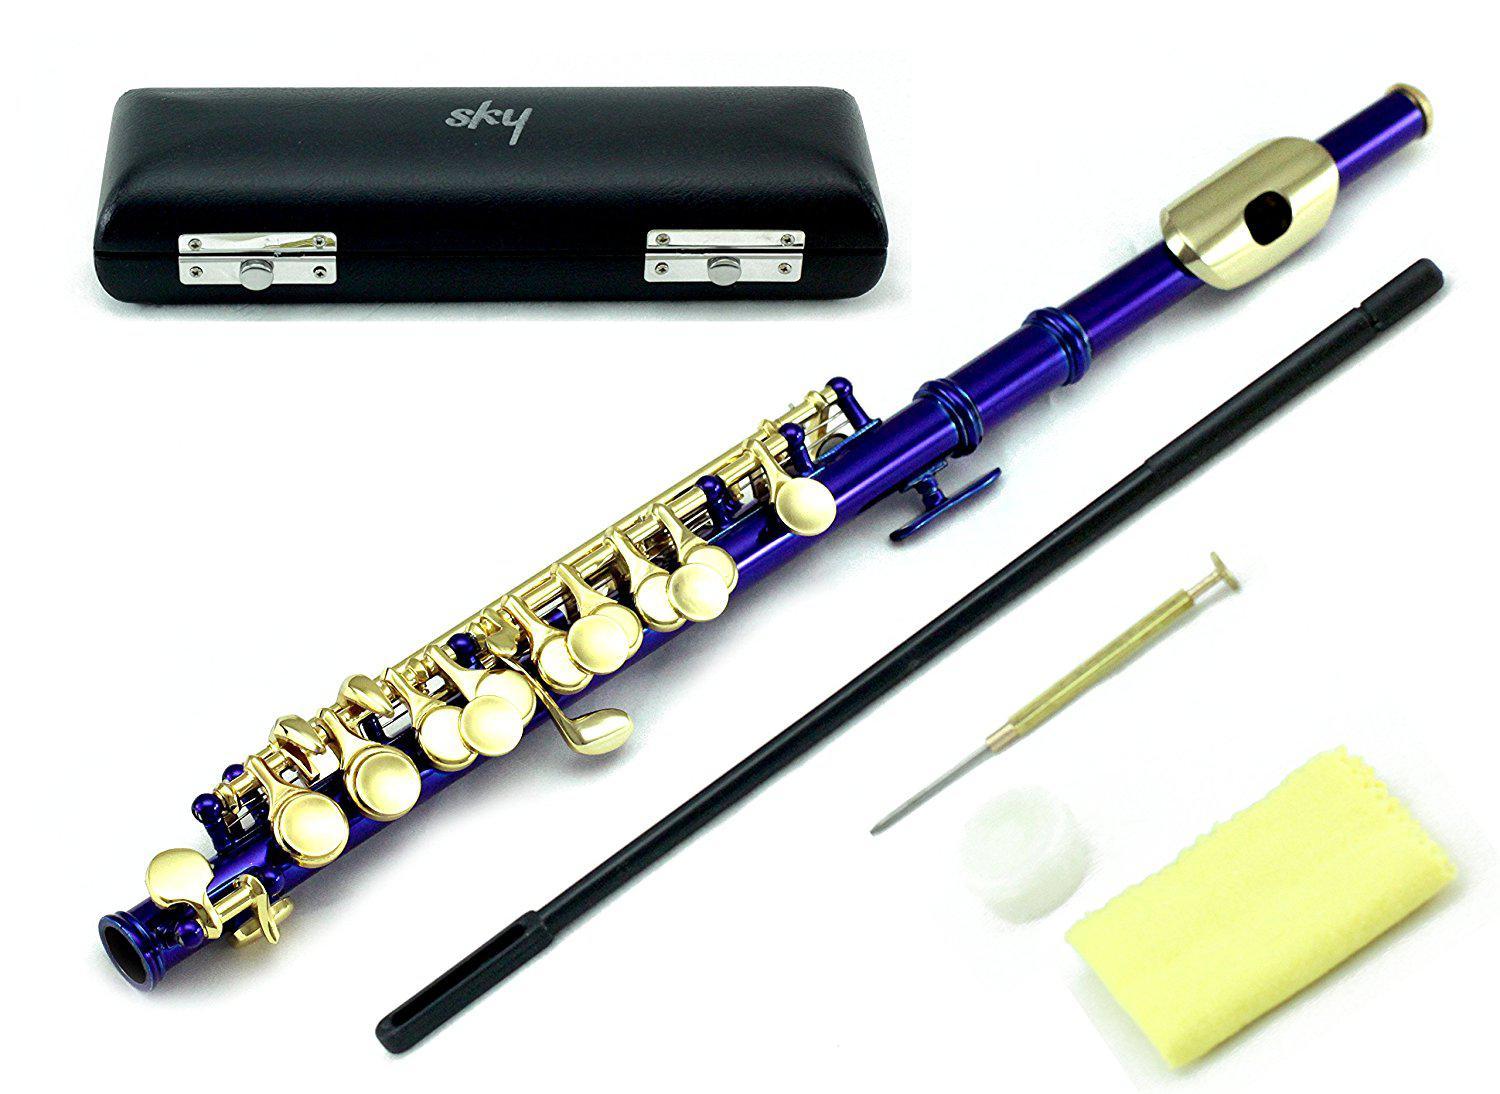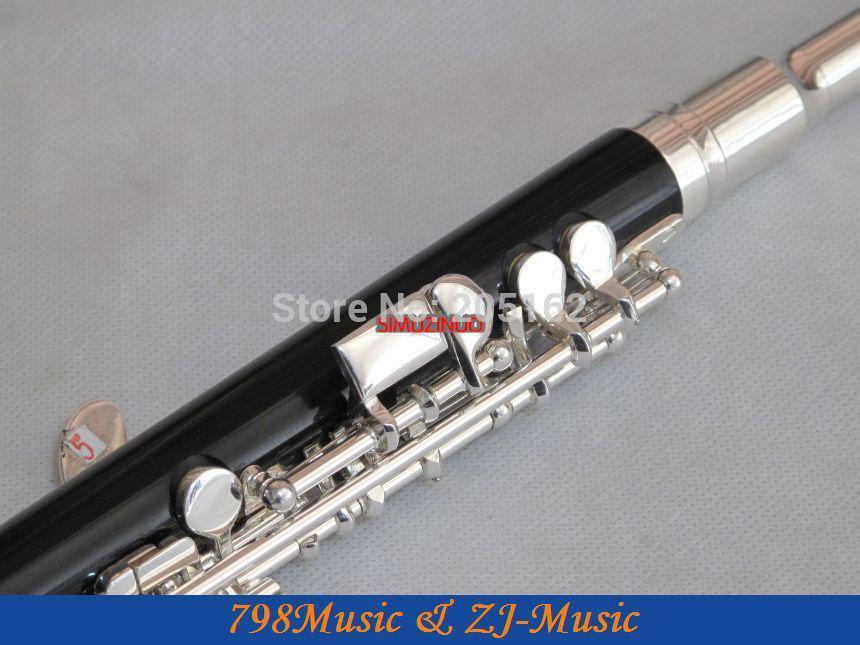The first image is the image on the left, the second image is the image on the right. Analyze the images presented: Is the assertion "The left image contains only a diagonally displayed flute with metal buttons, and the right image includes only a diagonally displayed flute without metal buttons." valid? Answer yes or no. No. 